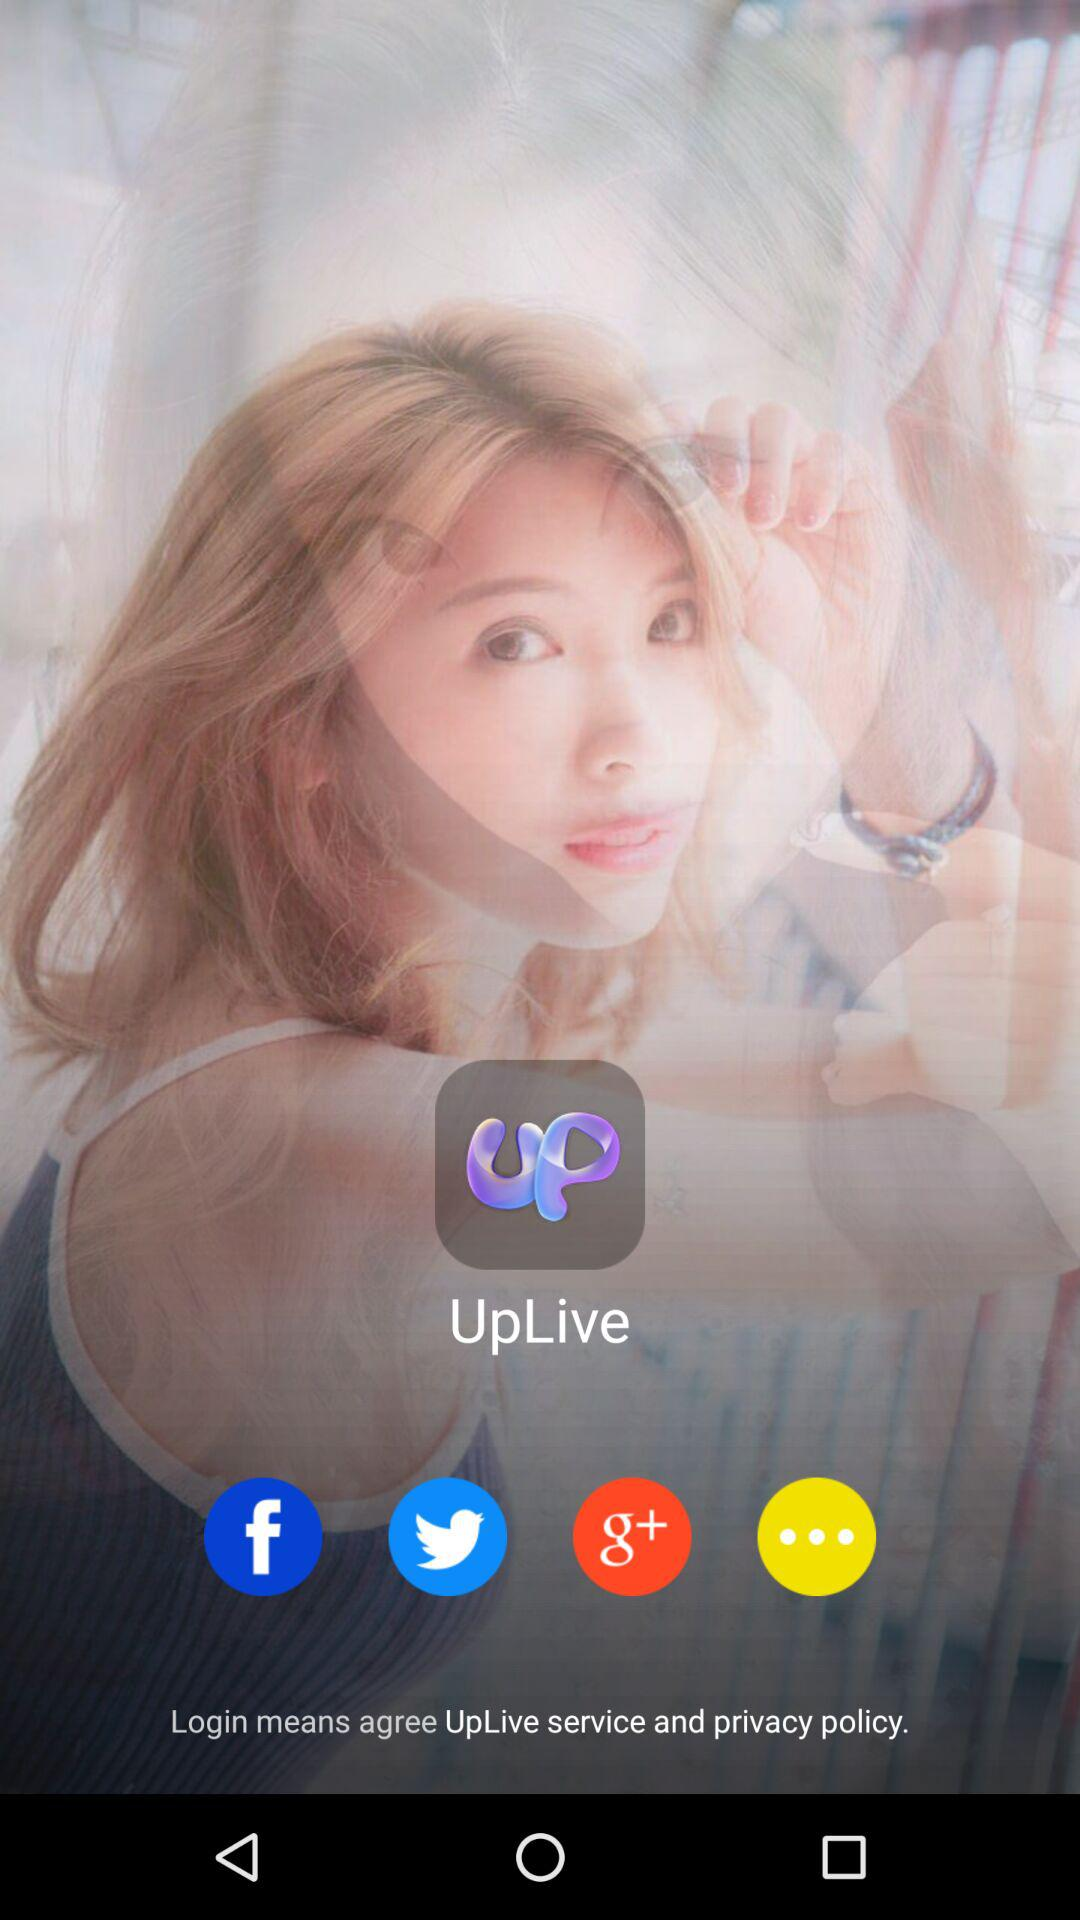What is the application name? The application name is "UpLive". 